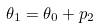<formula> <loc_0><loc_0><loc_500><loc_500>\theta _ { 1 } = \theta _ { 0 } + p _ { 2 }</formula> 